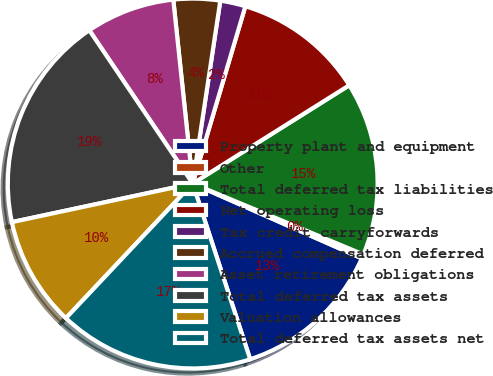Convert chart to OTSL. <chart><loc_0><loc_0><loc_500><loc_500><pie_chart><fcel>Property plant and equipment<fcel>Other<fcel>Total deferred tax liabilities<fcel>Net operating loss<fcel>Tax credit carryforwards<fcel>Accrued compensation deferred<fcel>Asset retirement obligations<fcel>Total deferred tax assets<fcel>Valuation allowances<fcel>Total deferred tax assets net<nl><fcel>13.34%<fcel>0.36%<fcel>15.19%<fcel>11.48%<fcel>2.21%<fcel>4.06%<fcel>7.77%<fcel>18.9%<fcel>9.63%<fcel>17.05%<nl></chart> 